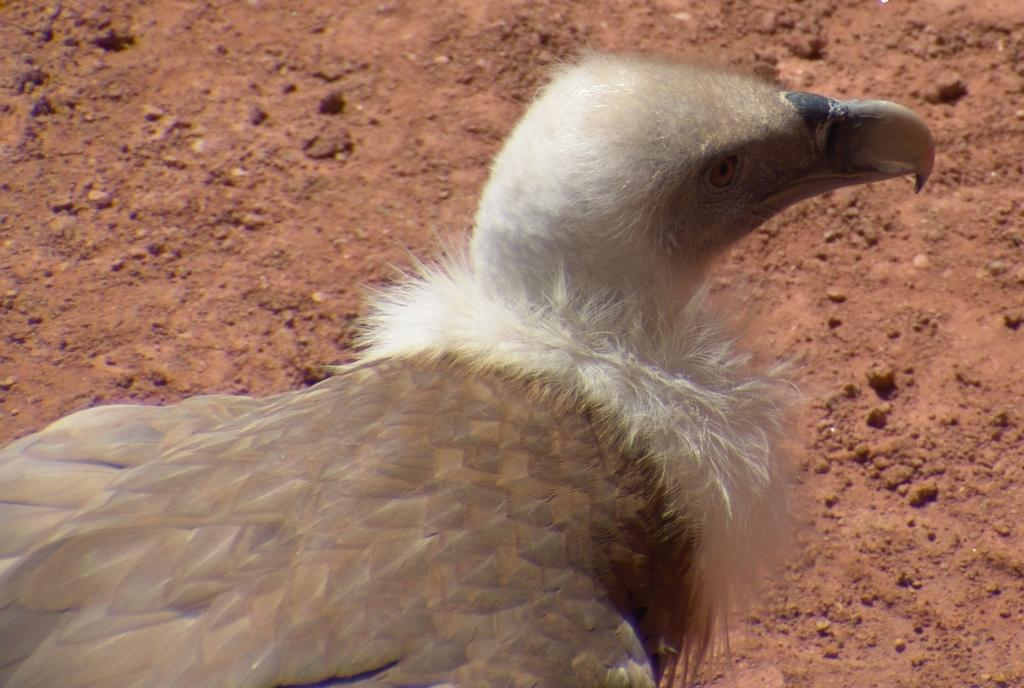What type of animal can be seen in the image? There is a bird in the image. Where is the bird located in the image? The bird is on the ground. What is the bird's memory capacity in the image? There is no information about the bird's memory capacity in the image. 